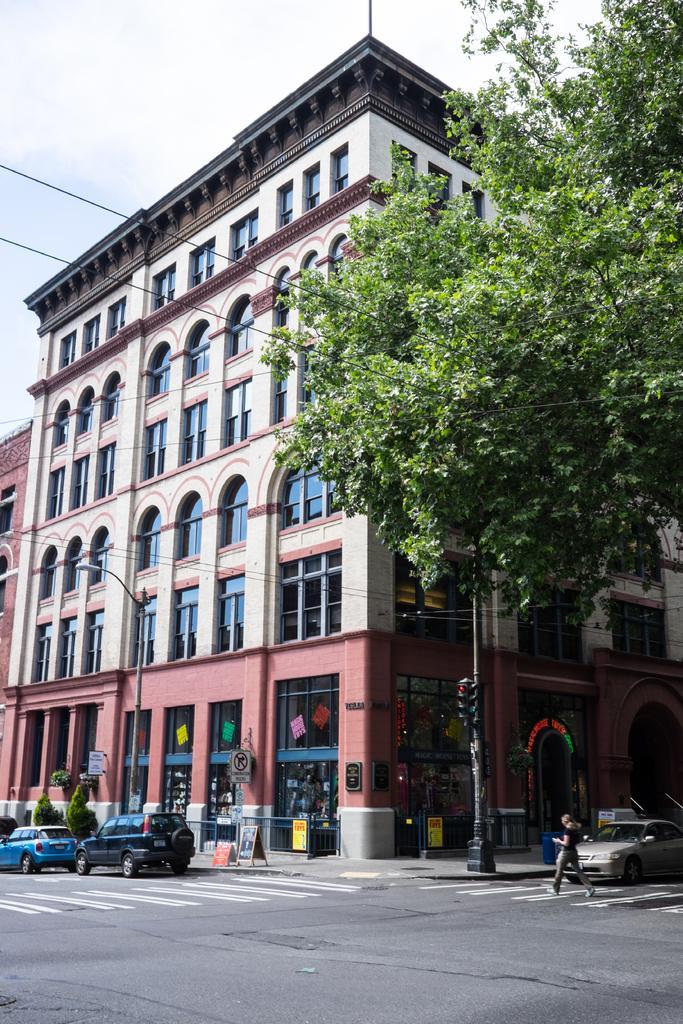How would you summarize this image in a sentence or two? In this image, we can see a building and tree. There are poles in the middle of the image. There are vehicles on the road. There is a sky at the top of the image. There is a person in the bottom right of the image walking on the road. 